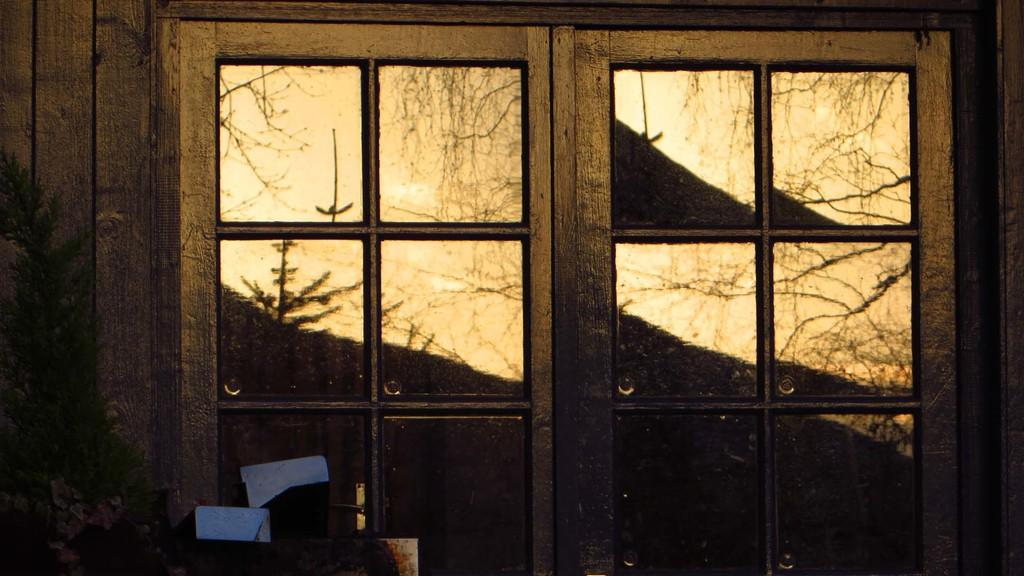What architectural feature is visible in the image? There are windows in the image. What material is the wall surrounding the windows made of? The windows are part of a wooden wall. What is located in front of the wall? There is a tree in front of the wall. What can be seen in the glass of the windows? The reflection of trees is visible in the glass of a window. What type of attention is the tree in the image paying to the wooden wall? Trees do not have the ability to pay attention, so this question cannot be answered. 